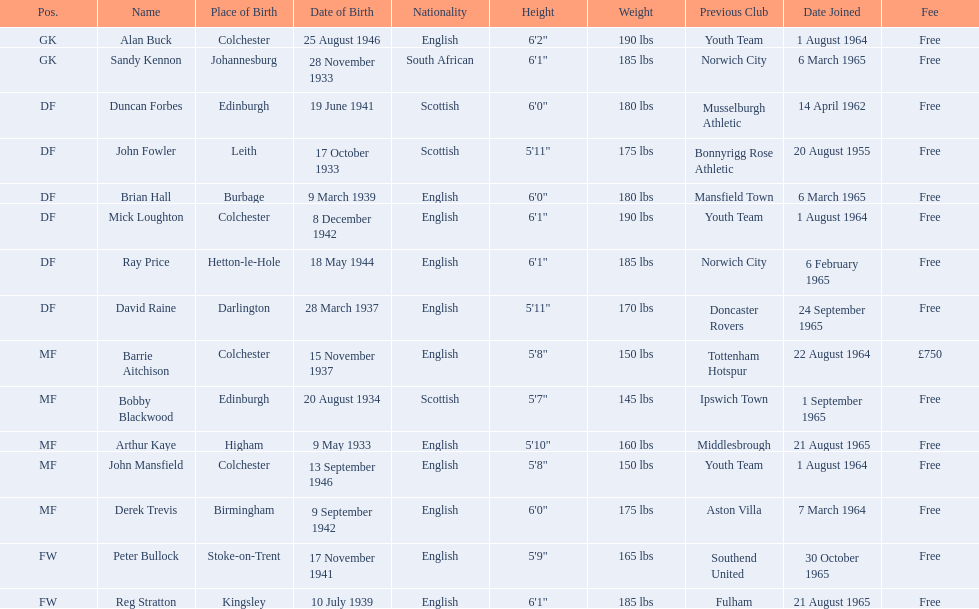What is the other fee listed, besides free? £750. 